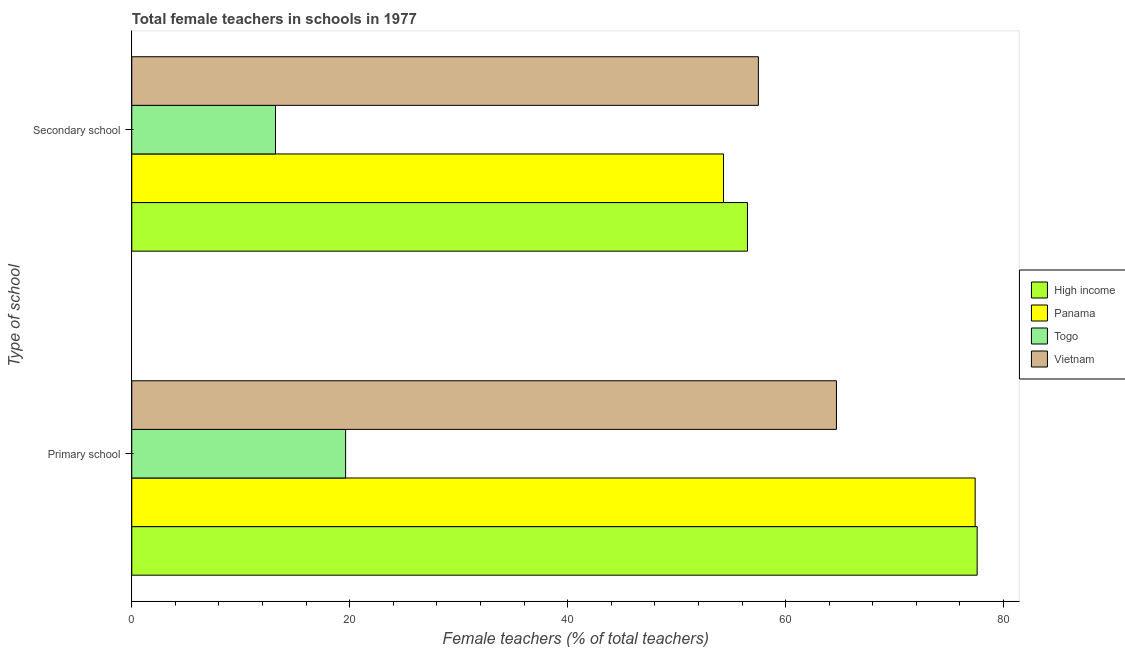Are the number of bars per tick equal to the number of legend labels?
Your answer should be compact. Yes. Are the number of bars on each tick of the Y-axis equal?
Your response must be concise. Yes. How many bars are there on the 1st tick from the top?
Offer a terse response. 4. How many bars are there on the 2nd tick from the bottom?
Offer a very short reply. 4. What is the label of the 1st group of bars from the top?
Your response must be concise. Secondary school. What is the percentage of female teachers in primary schools in Togo?
Provide a short and direct response. 19.62. Across all countries, what is the maximum percentage of female teachers in primary schools?
Provide a short and direct response. 77.58. Across all countries, what is the minimum percentage of female teachers in primary schools?
Your answer should be very brief. 19.62. In which country was the percentage of female teachers in secondary schools maximum?
Keep it short and to the point. Vietnam. In which country was the percentage of female teachers in secondary schools minimum?
Provide a short and direct response. Togo. What is the total percentage of female teachers in primary schools in the graph?
Keep it short and to the point. 239.26. What is the difference between the percentage of female teachers in secondary schools in Panama and that in High income?
Keep it short and to the point. -2.2. What is the difference between the percentage of female teachers in primary schools in High income and the percentage of female teachers in secondary schools in Panama?
Offer a terse response. 23.27. What is the average percentage of female teachers in secondary schools per country?
Ensure brevity in your answer.  45.37. What is the difference between the percentage of female teachers in primary schools and percentage of female teachers in secondary schools in Togo?
Make the answer very short. 6.43. In how many countries, is the percentage of female teachers in primary schools greater than 72 %?
Provide a short and direct response. 2. What is the ratio of the percentage of female teachers in primary schools in High income to that in Vietnam?
Offer a very short reply. 1.2. Is the percentage of female teachers in primary schools in Panama less than that in Togo?
Keep it short and to the point. No. In how many countries, is the percentage of female teachers in secondary schools greater than the average percentage of female teachers in secondary schools taken over all countries?
Your response must be concise. 3. What does the 1st bar from the top in Secondary school represents?
Your answer should be compact. Vietnam. What does the 4th bar from the bottom in Secondary school represents?
Your answer should be very brief. Vietnam. How many bars are there?
Your answer should be compact. 8. Are the values on the major ticks of X-axis written in scientific E-notation?
Make the answer very short. No. Does the graph contain any zero values?
Provide a succinct answer. No. Where does the legend appear in the graph?
Offer a terse response. Center right. How many legend labels are there?
Your answer should be compact. 4. What is the title of the graph?
Keep it short and to the point. Total female teachers in schools in 1977. What is the label or title of the X-axis?
Your answer should be compact. Female teachers (% of total teachers). What is the label or title of the Y-axis?
Keep it short and to the point. Type of school. What is the Female teachers (% of total teachers) in High income in Primary school?
Make the answer very short. 77.58. What is the Female teachers (% of total teachers) of Panama in Primary school?
Your answer should be compact. 77.39. What is the Female teachers (% of total teachers) in Togo in Primary school?
Make the answer very short. 19.62. What is the Female teachers (% of total teachers) in Vietnam in Primary school?
Offer a very short reply. 64.66. What is the Female teachers (% of total teachers) of High income in Secondary school?
Offer a very short reply. 56.5. What is the Female teachers (% of total teachers) in Panama in Secondary school?
Ensure brevity in your answer.  54.3. What is the Female teachers (% of total teachers) in Togo in Secondary school?
Offer a very short reply. 13.19. What is the Female teachers (% of total teachers) in Vietnam in Secondary school?
Keep it short and to the point. 57.5. Across all Type of school, what is the maximum Female teachers (% of total teachers) of High income?
Ensure brevity in your answer.  77.58. Across all Type of school, what is the maximum Female teachers (% of total teachers) in Panama?
Provide a succinct answer. 77.39. Across all Type of school, what is the maximum Female teachers (% of total teachers) of Togo?
Ensure brevity in your answer.  19.62. Across all Type of school, what is the maximum Female teachers (% of total teachers) in Vietnam?
Offer a very short reply. 64.66. Across all Type of school, what is the minimum Female teachers (% of total teachers) in High income?
Give a very brief answer. 56.5. Across all Type of school, what is the minimum Female teachers (% of total teachers) of Panama?
Give a very brief answer. 54.3. Across all Type of school, what is the minimum Female teachers (% of total teachers) in Togo?
Your answer should be very brief. 13.19. Across all Type of school, what is the minimum Female teachers (% of total teachers) of Vietnam?
Provide a succinct answer. 57.5. What is the total Female teachers (% of total teachers) in High income in the graph?
Your response must be concise. 134.08. What is the total Female teachers (% of total teachers) in Panama in the graph?
Your response must be concise. 131.69. What is the total Female teachers (% of total teachers) in Togo in the graph?
Ensure brevity in your answer.  32.81. What is the total Female teachers (% of total teachers) of Vietnam in the graph?
Keep it short and to the point. 122.16. What is the difference between the Female teachers (% of total teachers) in High income in Primary school and that in Secondary school?
Ensure brevity in your answer.  21.08. What is the difference between the Female teachers (% of total teachers) of Panama in Primary school and that in Secondary school?
Your response must be concise. 23.09. What is the difference between the Female teachers (% of total teachers) of Togo in Primary school and that in Secondary school?
Your answer should be very brief. 6.43. What is the difference between the Female teachers (% of total teachers) in Vietnam in Primary school and that in Secondary school?
Keep it short and to the point. 7.17. What is the difference between the Female teachers (% of total teachers) of High income in Primary school and the Female teachers (% of total teachers) of Panama in Secondary school?
Keep it short and to the point. 23.27. What is the difference between the Female teachers (% of total teachers) in High income in Primary school and the Female teachers (% of total teachers) in Togo in Secondary school?
Keep it short and to the point. 64.39. What is the difference between the Female teachers (% of total teachers) of High income in Primary school and the Female teachers (% of total teachers) of Vietnam in Secondary school?
Your answer should be very brief. 20.08. What is the difference between the Female teachers (% of total teachers) of Panama in Primary school and the Female teachers (% of total teachers) of Togo in Secondary school?
Your response must be concise. 64.2. What is the difference between the Female teachers (% of total teachers) in Panama in Primary school and the Female teachers (% of total teachers) in Vietnam in Secondary school?
Provide a short and direct response. 19.89. What is the difference between the Female teachers (% of total teachers) in Togo in Primary school and the Female teachers (% of total teachers) in Vietnam in Secondary school?
Ensure brevity in your answer.  -37.88. What is the average Female teachers (% of total teachers) in High income per Type of school?
Offer a very short reply. 67.04. What is the average Female teachers (% of total teachers) of Panama per Type of school?
Your response must be concise. 65.85. What is the average Female teachers (% of total teachers) of Togo per Type of school?
Provide a short and direct response. 16.41. What is the average Female teachers (% of total teachers) of Vietnam per Type of school?
Your answer should be very brief. 61.08. What is the difference between the Female teachers (% of total teachers) of High income and Female teachers (% of total teachers) of Panama in Primary school?
Your answer should be very brief. 0.18. What is the difference between the Female teachers (% of total teachers) in High income and Female teachers (% of total teachers) in Togo in Primary school?
Make the answer very short. 57.95. What is the difference between the Female teachers (% of total teachers) of High income and Female teachers (% of total teachers) of Vietnam in Primary school?
Offer a terse response. 12.91. What is the difference between the Female teachers (% of total teachers) of Panama and Female teachers (% of total teachers) of Togo in Primary school?
Keep it short and to the point. 57.77. What is the difference between the Female teachers (% of total teachers) in Panama and Female teachers (% of total teachers) in Vietnam in Primary school?
Offer a terse response. 12.73. What is the difference between the Female teachers (% of total teachers) in Togo and Female teachers (% of total teachers) in Vietnam in Primary school?
Your response must be concise. -45.04. What is the difference between the Female teachers (% of total teachers) in High income and Female teachers (% of total teachers) in Panama in Secondary school?
Your answer should be very brief. 2.2. What is the difference between the Female teachers (% of total teachers) of High income and Female teachers (% of total teachers) of Togo in Secondary school?
Keep it short and to the point. 43.31. What is the difference between the Female teachers (% of total teachers) in High income and Female teachers (% of total teachers) in Vietnam in Secondary school?
Offer a terse response. -1. What is the difference between the Female teachers (% of total teachers) in Panama and Female teachers (% of total teachers) in Togo in Secondary school?
Give a very brief answer. 41.11. What is the difference between the Female teachers (% of total teachers) of Panama and Female teachers (% of total teachers) of Vietnam in Secondary school?
Make the answer very short. -3.2. What is the difference between the Female teachers (% of total teachers) in Togo and Female teachers (% of total teachers) in Vietnam in Secondary school?
Provide a succinct answer. -44.31. What is the ratio of the Female teachers (% of total teachers) of High income in Primary school to that in Secondary school?
Your response must be concise. 1.37. What is the ratio of the Female teachers (% of total teachers) of Panama in Primary school to that in Secondary school?
Your answer should be very brief. 1.43. What is the ratio of the Female teachers (% of total teachers) in Togo in Primary school to that in Secondary school?
Provide a succinct answer. 1.49. What is the ratio of the Female teachers (% of total teachers) of Vietnam in Primary school to that in Secondary school?
Ensure brevity in your answer.  1.12. What is the difference between the highest and the second highest Female teachers (% of total teachers) of High income?
Provide a short and direct response. 21.08. What is the difference between the highest and the second highest Female teachers (% of total teachers) of Panama?
Give a very brief answer. 23.09. What is the difference between the highest and the second highest Female teachers (% of total teachers) of Togo?
Ensure brevity in your answer.  6.43. What is the difference between the highest and the second highest Female teachers (% of total teachers) in Vietnam?
Keep it short and to the point. 7.17. What is the difference between the highest and the lowest Female teachers (% of total teachers) in High income?
Your response must be concise. 21.08. What is the difference between the highest and the lowest Female teachers (% of total teachers) in Panama?
Ensure brevity in your answer.  23.09. What is the difference between the highest and the lowest Female teachers (% of total teachers) in Togo?
Ensure brevity in your answer.  6.43. What is the difference between the highest and the lowest Female teachers (% of total teachers) in Vietnam?
Provide a short and direct response. 7.17. 